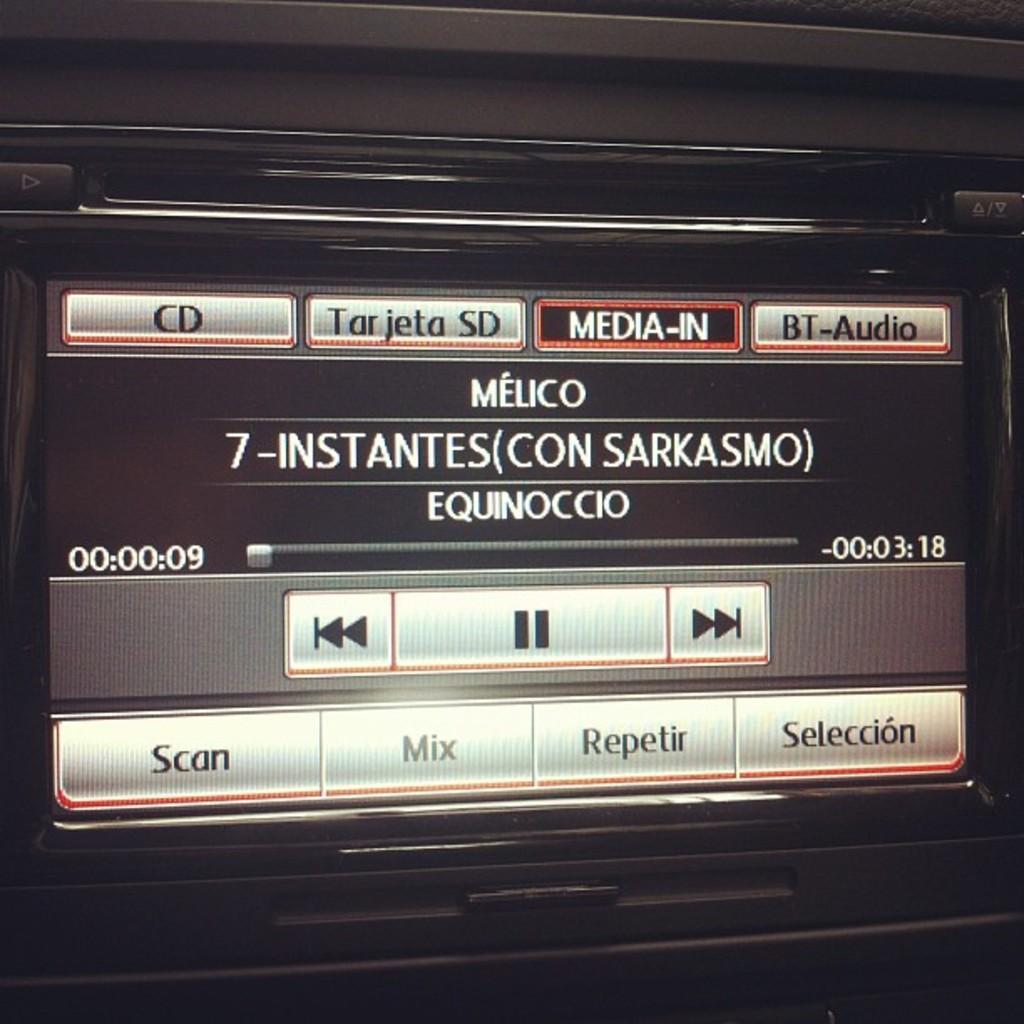How would you summarize this image in a sentence or two? In the picture we can see a tape recorder with a screen on it, we can see, options like to scan mix, repeater, selection, and we can also see some other options like media in BT audio. 